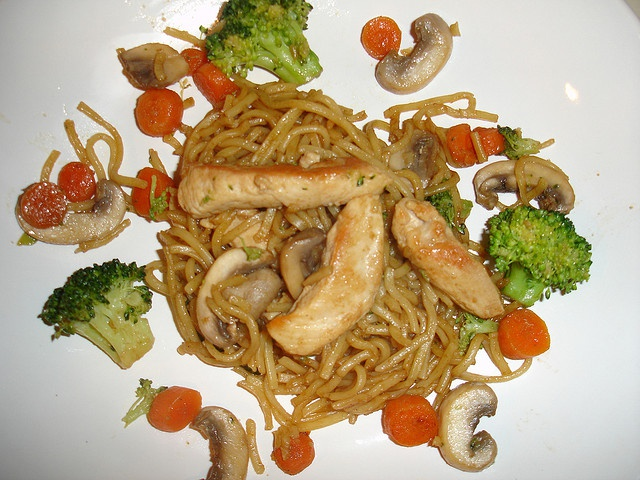Describe the objects in this image and their specific colors. I can see broccoli in darkgray, olive, black, and lightgray tones, broccoli in darkgray and olive tones, broccoli in darkgray and olive tones, carrot in darkgray, maroon, and brown tones, and carrot in darkgray, red, brown, and white tones in this image. 